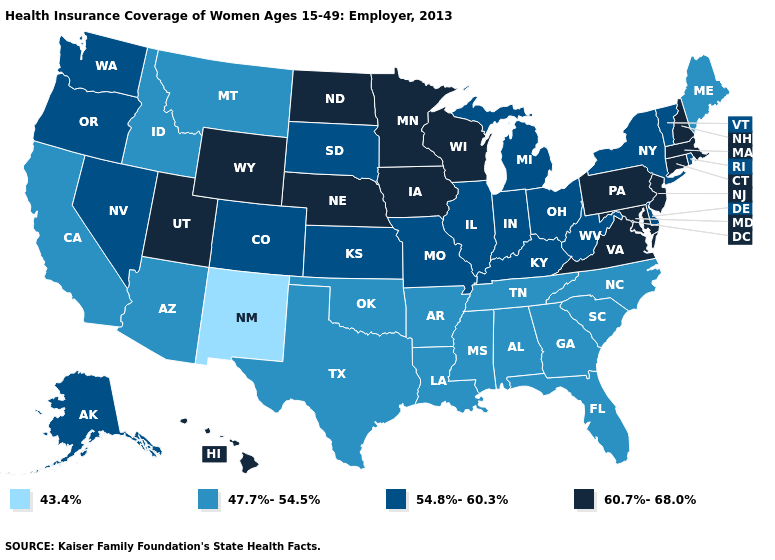What is the value of Hawaii?
Write a very short answer. 60.7%-68.0%. What is the lowest value in the South?
Quick response, please. 47.7%-54.5%. Among the states that border Missouri , does Tennessee have the lowest value?
Quick response, please. Yes. Is the legend a continuous bar?
Quick response, please. No. Does Massachusetts have the highest value in the USA?
Short answer required. Yes. What is the highest value in states that border Georgia?
Be succinct. 47.7%-54.5%. Which states have the lowest value in the South?
Short answer required. Alabama, Arkansas, Florida, Georgia, Louisiana, Mississippi, North Carolina, Oklahoma, South Carolina, Tennessee, Texas. Does the map have missing data?
Answer briefly. No. Among the states that border Idaho , does Wyoming have the highest value?
Quick response, please. Yes. Which states have the lowest value in the USA?
Answer briefly. New Mexico. Does South Dakota have the lowest value in the MidWest?
Answer briefly. Yes. Among the states that border Illinois , does Indiana have the lowest value?
Answer briefly. Yes. Which states have the highest value in the USA?
Keep it brief. Connecticut, Hawaii, Iowa, Maryland, Massachusetts, Minnesota, Nebraska, New Hampshire, New Jersey, North Dakota, Pennsylvania, Utah, Virginia, Wisconsin, Wyoming. Among the states that border Ohio , which have the highest value?
Quick response, please. Pennsylvania. What is the lowest value in the West?
Write a very short answer. 43.4%. 